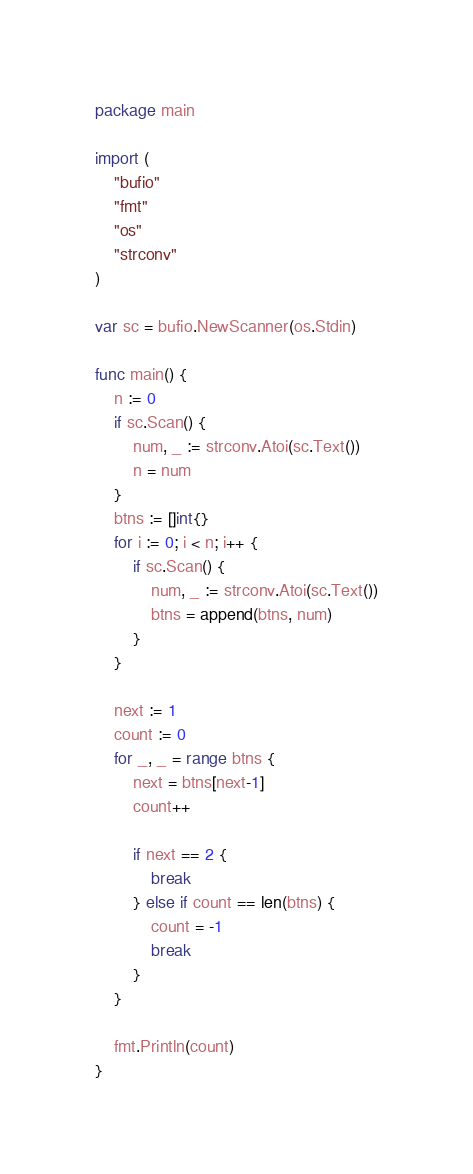<code> <loc_0><loc_0><loc_500><loc_500><_Go_>package main

import (
	"bufio"
	"fmt"
	"os"
	"strconv"
)

var sc = bufio.NewScanner(os.Stdin)

func main() {
	n := 0
	if sc.Scan() {
		num, _ := strconv.Atoi(sc.Text())
		n = num
	}
	btns := []int{}
	for i := 0; i < n; i++ {
		if sc.Scan() {
			num, _ := strconv.Atoi(sc.Text())
			btns = append(btns, num)
		}
	}

	next := 1
	count := 0
	for _, _ = range btns {
		next = btns[next-1]
		count++

		if next == 2 {
			break
		} else if count == len(btns) {
			count = -1
			break
		}
	}

	fmt.Println(count)
}
</code> 